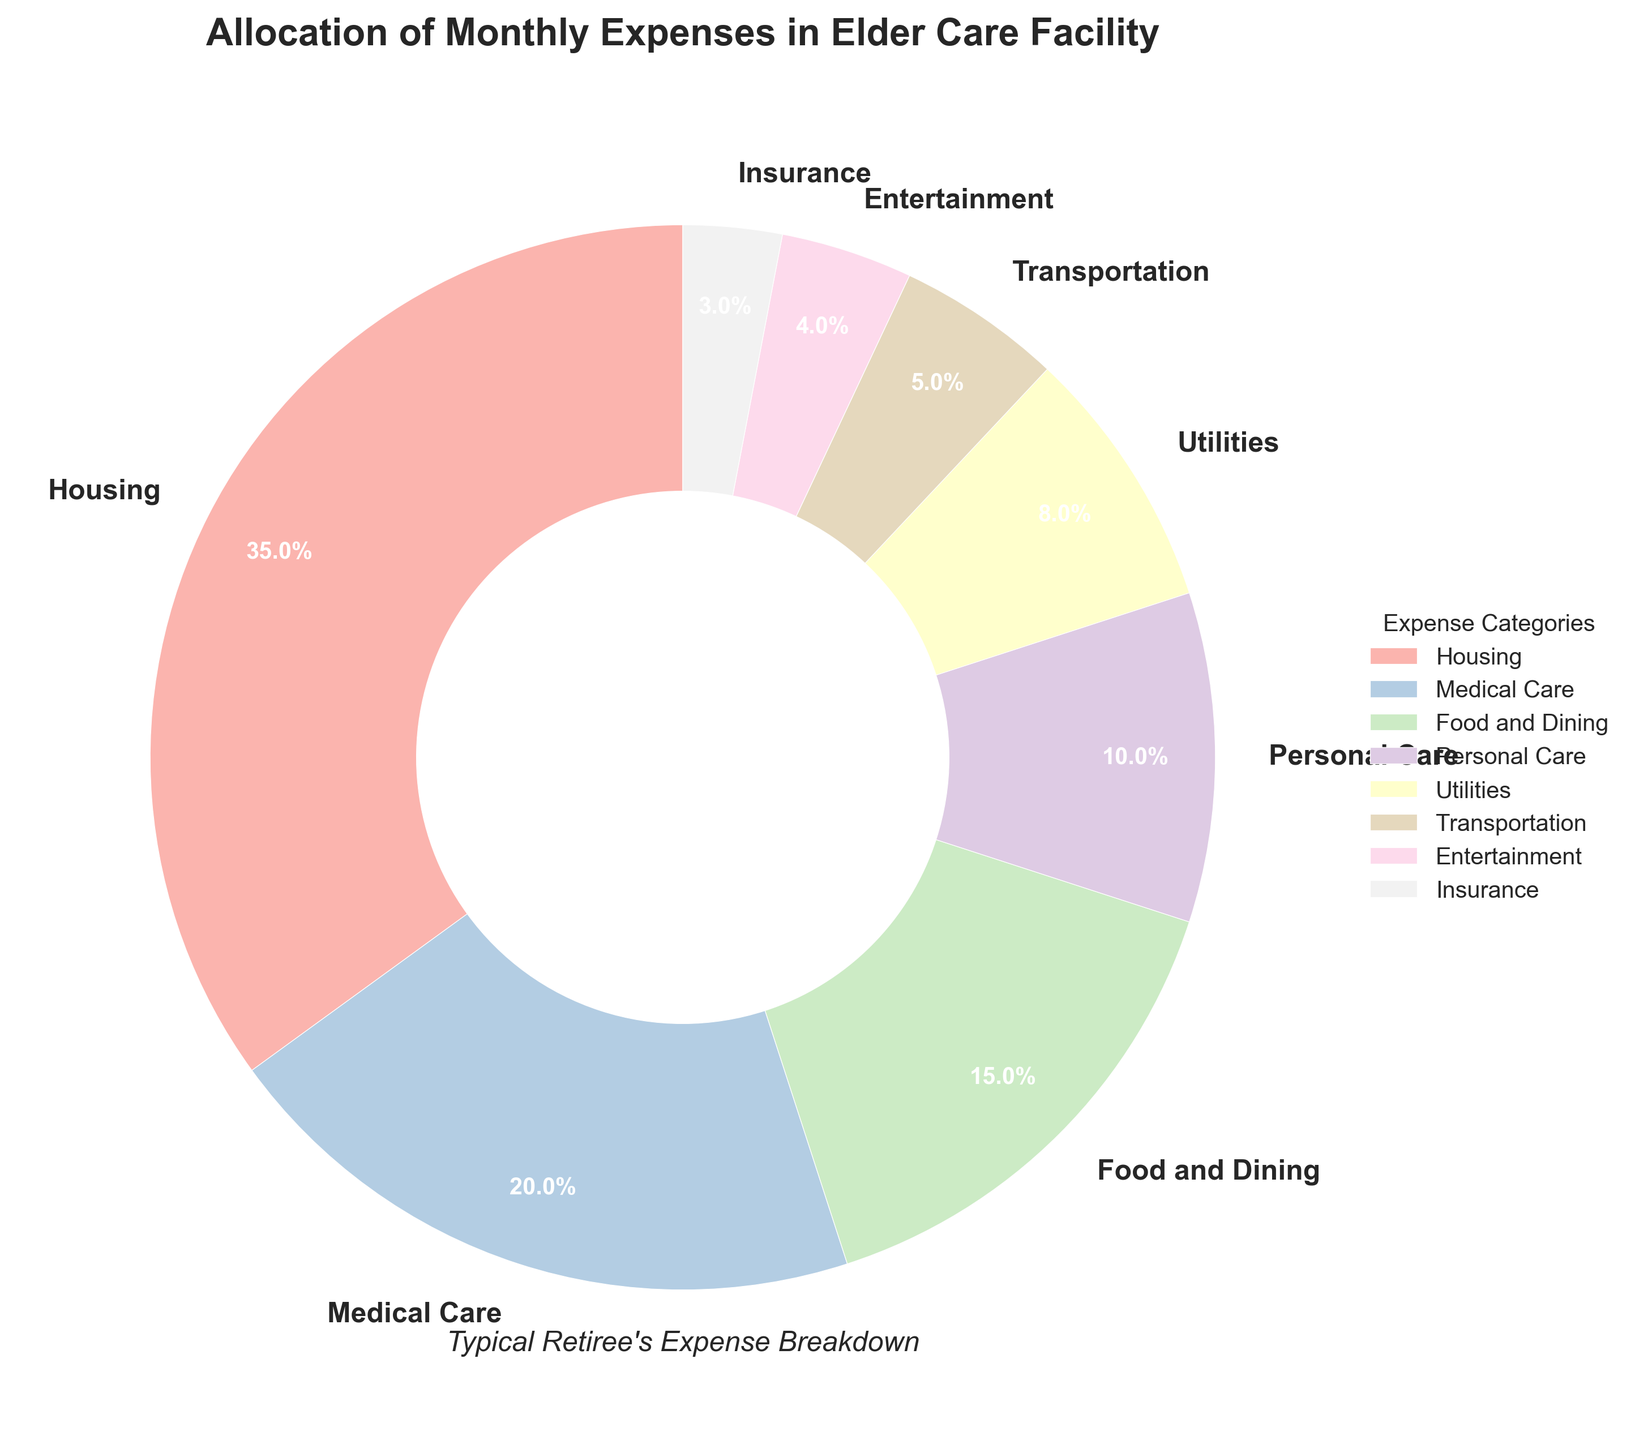What percentage of the typical retiree's expenses is allocated to Medical Care? Look at the "Medical Care" slice on the pie chart and read the indicated percentage.
Answer: 20% What is the combined percentage of expenses for Utilities and Transportation? Identify the percentages for Utilities (8%) and Transportation (5%) and add them together: 8% + 5% = 13%.
Answer: 13% How does the percentage allocated to Food and Dining compare to that allocated to Personal Care? Look at the slices for Food and Dining (15%) and Personal Care (10%) and compare them: 15% is greater than 10%.
Answer: Food and Dining is greater Which category has the smallest allocation in the budget? Look for the smallest slice in the pie chart. The slice for Insurance is the smallest with 3%.
Answer: Insurance What is the total percentage allocated to Housing, Medical Care, and Food and Dining? Sum the percentages for Housing (35%), Medical Care (20%), and Food and Dining (15%): 35% + 20% + 15% = 70%.
Answer: 70% Which categories combined account for more than half of the typical retiree's expenses? Sum categories starting from the largest until the sum exceeds 50%. Housing (35%) + Medical Care (20%) = 55%, which is more than half.
Answer: Housing and Medical Care What is the difference in percentage between Housing and Utilities? Look at the percentages for Housing (35%) and Utilities (8%) and compute the difference: 35% - 8% = 27%.
Answer: 27% Which category is represented by the darkest color in the pie chart? Visually identify the slice with the darkest color; typically, the largest slice would have the darkest shade in a pastel palette.
Answer: Housing Is the percentage allocated to Entertainment higher or lower than that allocated to Transportation? Compare the slices for Entertainment (4%) and Transportation (5%); Entertainment is lower.
Answer: Lower What percentage of the expenses are allocated to categories other than Housing? Subtract the percentage for Housing (35%) from 100%: 100% - 35% = 65%.
Answer: 65% 